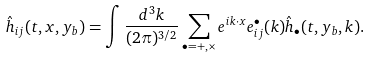<formula> <loc_0><loc_0><loc_500><loc_500>\hat { h } _ { i j } ( t , { x } , y _ { b } ) = \int \frac { d ^ { 3 } k } { ( 2 \pi ) ^ { 3 / 2 } } \sum _ { \bullet = + , \times } e ^ { i { k \cdot x } } e ^ { \bullet } _ { i j } ( { k } ) \hat { h } _ { \bullet } ( t , y _ { b } , { k } ) .</formula> 